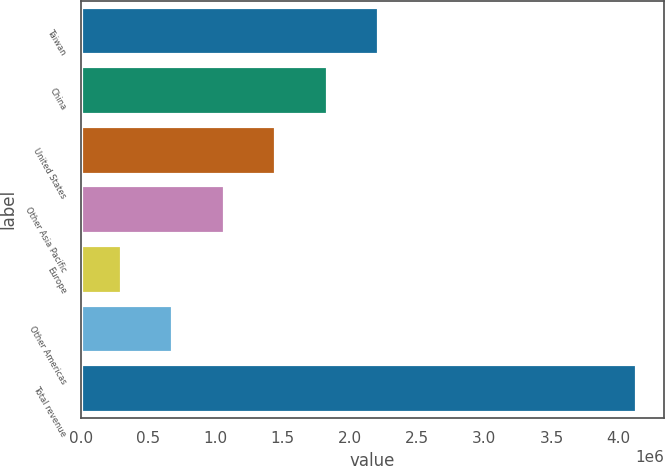<chart> <loc_0><loc_0><loc_500><loc_500><bar_chart><fcel>Taiwan<fcel>China<fcel>United States<fcel>Other Asia Pacific<fcel>Europe<fcel>Other Americas<fcel>Total revenue<nl><fcel>2.21266e+06<fcel>1.82916e+06<fcel>1.44566e+06<fcel>1.06216e+06<fcel>295160<fcel>678660<fcel>4.13016e+06<nl></chart> 